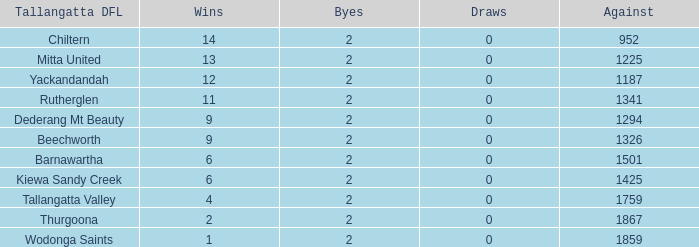What is the most byes with 11 wins and fewer than 1867 againsts? 2.0. 